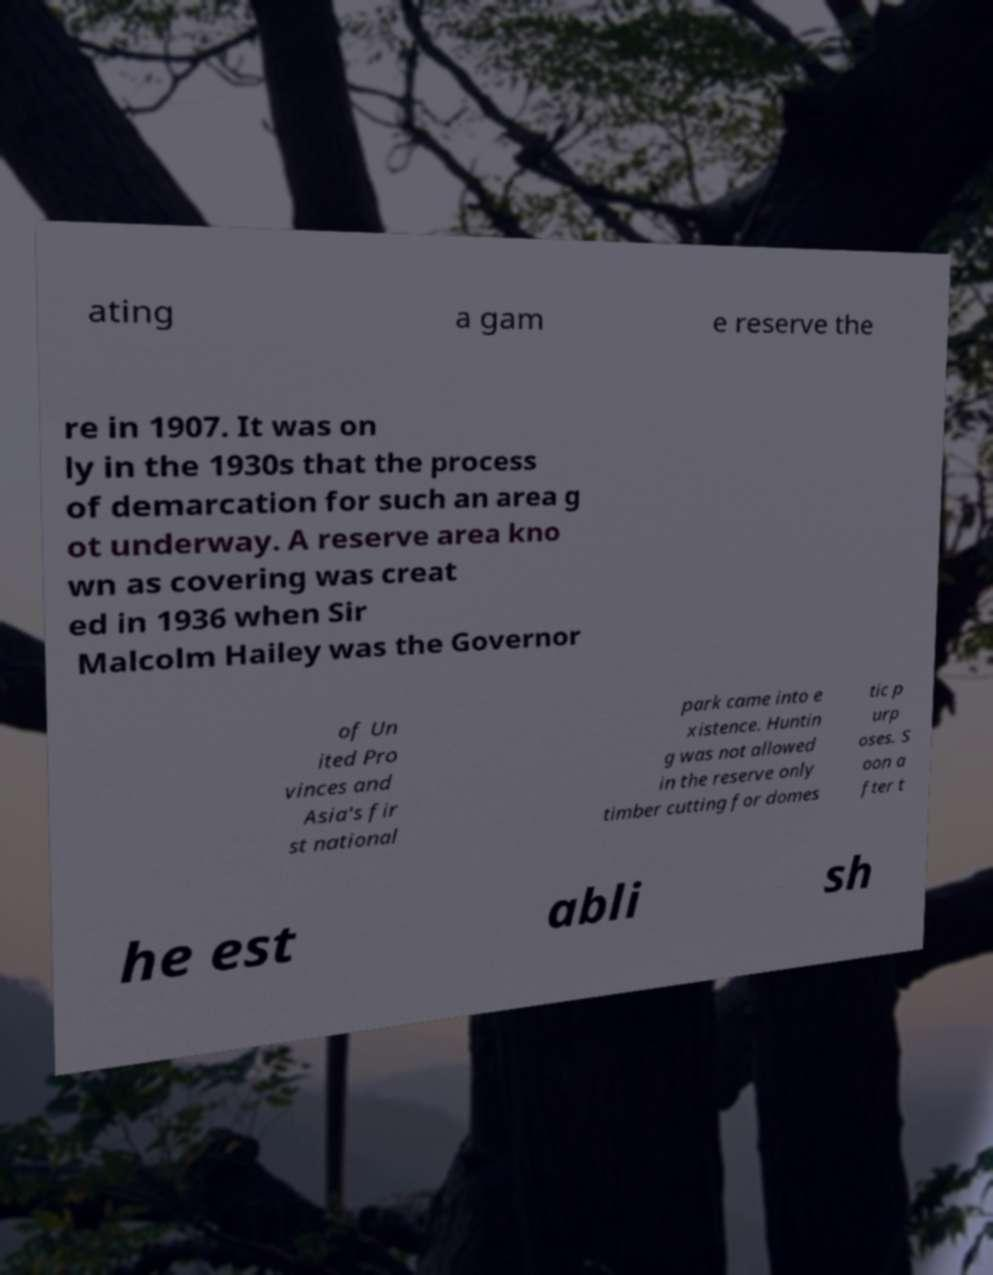Can you accurately transcribe the text from the provided image for me? ating a gam e reserve the re in 1907. It was on ly in the 1930s that the process of demarcation for such an area g ot underway. A reserve area kno wn as covering was creat ed in 1936 when Sir Malcolm Hailey was the Governor of Un ited Pro vinces and Asia's fir st national park came into e xistence. Huntin g was not allowed in the reserve only timber cutting for domes tic p urp oses. S oon a fter t he est abli sh 